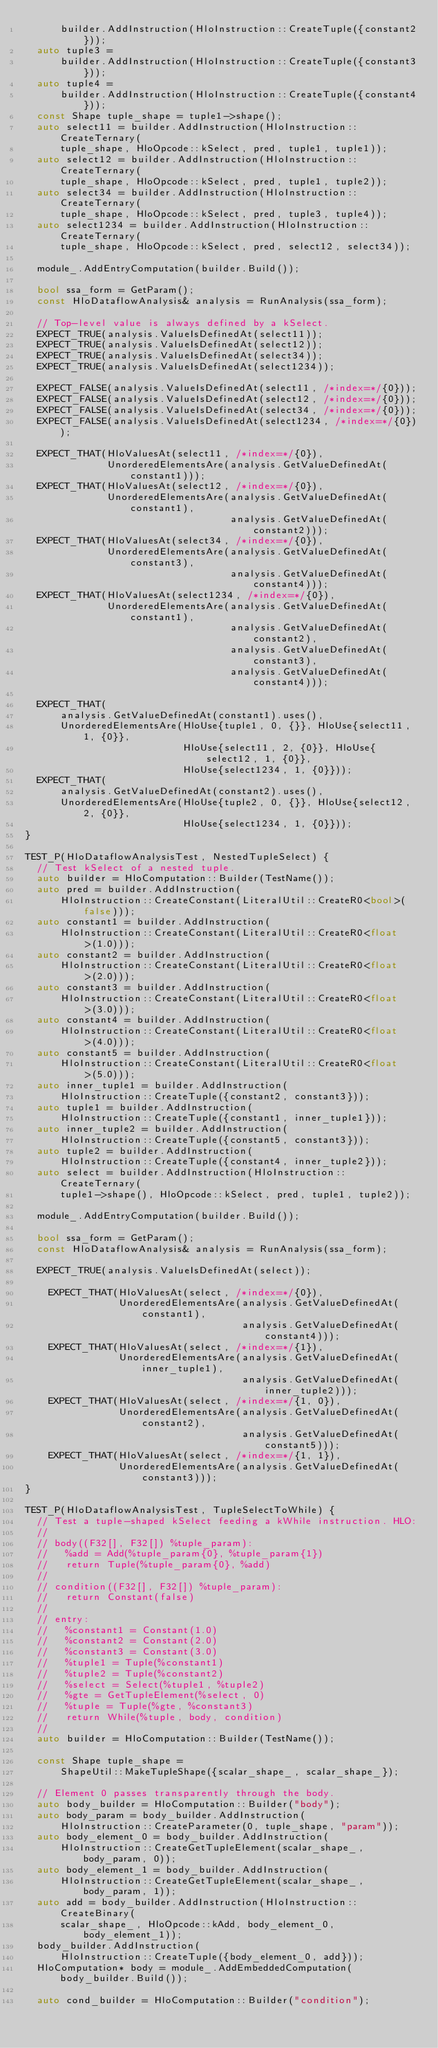Convert code to text. <code><loc_0><loc_0><loc_500><loc_500><_C++_>      builder.AddInstruction(HloInstruction::CreateTuple({constant2}));
  auto tuple3 =
      builder.AddInstruction(HloInstruction::CreateTuple({constant3}));
  auto tuple4 =
      builder.AddInstruction(HloInstruction::CreateTuple({constant4}));
  const Shape tuple_shape = tuple1->shape();
  auto select11 = builder.AddInstruction(HloInstruction::CreateTernary(
      tuple_shape, HloOpcode::kSelect, pred, tuple1, tuple1));
  auto select12 = builder.AddInstruction(HloInstruction::CreateTernary(
      tuple_shape, HloOpcode::kSelect, pred, tuple1, tuple2));
  auto select34 = builder.AddInstruction(HloInstruction::CreateTernary(
      tuple_shape, HloOpcode::kSelect, pred, tuple3, tuple4));
  auto select1234 = builder.AddInstruction(HloInstruction::CreateTernary(
      tuple_shape, HloOpcode::kSelect, pred, select12, select34));

  module_.AddEntryComputation(builder.Build());

  bool ssa_form = GetParam();
  const HloDataflowAnalysis& analysis = RunAnalysis(ssa_form);

  // Top-level value is always defined by a kSelect.
  EXPECT_TRUE(analysis.ValueIsDefinedAt(select11));
  EXPECT_TRUE(analysis.ValueIsDefinedAt(select12));
  EXPECT_TRUE(analysis.ValueIsDefinedAt(select34));
  EXPECT_TRUE(analysis.ValueIsDefinedAt(select1234));

  EXPECT_FALSE(analysis.ValueIsDefinedAt(select11, /*index=*/{0}));
  EXPECT_FALSE(analysis.ValueIsDefinedAt(select12, /*index=*/{0}));
  EXPECT_FALSE(analysis.ValueIsDefinedAt(select34, /*index=*/{0}));
  EXPECT_FALSE(analysis.ValueIsDefinedAt(select1234, /*index=*/{0}));

  EXPECT_THAT(HloValuesAt(select11, /*index=*/{0}),
              UnorderedElementsAre(analysis.GetValueDefinedAt(constant1)));
  EXPECT_THAT(HloValuesAt(select12, /*index=*/{0}),
              UnorderedElementsAre(analysis.GetValueDefinedAt(constant1),
                                   analysis.GetValueDefinedAt(constant2)));
  EXPECT_THAT(HloValuesAt(select34, /*index=*/{0}),
              UnorderedElementsAre(analysis.GetValueDefinedAt(constant3),
                                   analysis.GetValueDefinedAt(constant4)));
  EXPECT_THAT(HloValuesAt(select1234, /*index=*/{0}),
              UnorderedElementsAre(analysis.GetValueDefinedAt(constant1),
                                   analysis.GetValueDefinedAt(constant2),
                                   analysis.GetValueDefinedAt(constant3),
                                   analysis.GetValueDefinedAt(constant4)));

  EXPECT_THAT(
      analysis.GetValueDefinedAt(constant1).uses(),
      UnorderedElementsAre(HloUse{tuple1, 0, {}}, HloUse{select11, 1, {0}},
                           HloUse{select11, 2, {0}}, HloUse{select12, 1, {0}},
                           HloUse{select1234, 1, {0}}));
  EXPECT_THAT(
      analysis.GetValueDefinedAt(constant2).uses(),
      UnorderedElementsAre(HloUse{tuple2, 0, {}}, HloUse{select12, 2, {0}},
                           HloUse{select1234, 1, {0}}));
}

TEST_P(HloDataflowAnalysisTest, NestedTupleSelect) {
  // Test kSelect of a nested tuple.
  auto builder = HloComputation::Builder(TestName());
  auto pred = builder.AddInstruction(
      HloInstruction::CreateConstant(LiteralUtil::CreateR0<bool>(false)));
  auto constant1 = builder.AddInstruction(
      HloInstruction::CreateConstant(LiteralUtil::CreateR0<float>(1.0)));
  auto constant2 = builder.AddInstruction(
      HloInstruction::CreateConstant(LiteralUtil::CreateR0<float>(2.0)));
  auto constant3 = builder.AddInstruction(
      HloInstruction::CreateConstant(LiteralUtil::CreateR0<float>(3.0)));
  auto constant4 = builder.AddInstruction(
      HloInstruction::CreateConstant(LiteralUtil::CreateR0<float>(4.0)));
  auto constant5 = builder.AddInstruction(
      HloInstruction::CreateConstant(LiteralUtil::CreateR0<float>(5.0)));
  auto inner_tuple1 = builder.AddInstruction(
      HloInstruction::CreateTuple({constant2, constant3}));
  auto tuple1 = builder.AddInstruction(
      HloInstruction::CreateTuple({constant1, inner_tuple1}));
  auto inner_tuple2 = builder.AddInstruction(
      HloInstruction::CreateTuple({constant5, constant3}));
  auto tuple2 = builder.AddInstruction(
      HloInstruction::CreateTuple({constant4, inner_tuple2}));
  auto select = builder.AddInstruction(HloInstruction::CreateTernary(
      tuple1->shape(), HloOpcode::kSelect, pred, tuple1, tuple2));

  module_.AddEntryComputation(builder.Build());

  bool ssa_form = GetParam();
  const HloDataflowAnalysis& analysis = RunAnalysis(ssa_form);

  EXPECT_TRUE(analysis.ValueIsDefinedAt(select));

    EXPECT_THAT(HloValuesAt(select, /*index=*/{0}),
                UnorderedElementsAre(analysis.GetValueDefinedAt(constant1),
                                     analysis.GetValueDefinedAt(constant4)));
    EXPECT_THAT(HloValuesAt(select, /*index=*/{1}),
                UnorderedElementsAre(analysis.GetValueDefinedAt(inner_tuple1),
                                     analysis.GetValueDefinedAt(inner_tuple2)));
    EXPECT_THAT(HloValuesAt(select, /*index=*/{1, 0}),
                UnorderedElementsAre(analysis.GetValueDefinedAt(constant2),
                                     analysis.GetValueDefinedAt(constant5)));
    EXPECT_THAT(HloValuesAt(select, /*index=*/{1, 1}),
                UnorderedElementsAre(analysis.GetValueDefinedAt(constant3)));
}

TEST_P(HloDataflowAnalysisTest, TupleSelectToWhile) {
  // Test a tuple-shaped kSelect feeding a kWhile instruction. HLO:
  //
  // body((F32[], F32[]) %tuple_param):
  //   %add = Add(%tuple_param{0}, %tuple_param{1})
  //   return Tuple(%tuple_param{0}, %add)
  //
  // condition((F32[], F32[]) %tuple_param):
  //   return Constant(false)
  //
  // entry:
  //   %constant1 = Constant(1.0)
  //   %constant2 = Constant(2.0)
  //   %constant3 = Constant(3.0)
  //   %tuple1 = Tuple(%constant1)
  //   %tuple2 = Tuple(%constant2)
  //   %select = Select(%tuple1, %tuple2)
  //   %gte = GetTupleElement(%select, 0)
  //   %tuple = Tuple(%gte, %constant3)
  //   return While(%tuple, body, condition)
  //
  auto builder = HloComputation::Builder(TestName());

  const Shape tuple_shape =
      ShapeUtil::MakeTupleShape({scalar_shape_, scalar_shape_});

  // Element 0 passes transparently through the body.
  auto body_builder = HloComputation::Builder("body");
  auto body_param = body_builder.AddInstruction(
      HloInstruction::CreateParameter(0, tuple_shape, "param"));
  auto body_element_0 = body_builder.AddInstruction(
      HloInstruction::CreateGetTupleElement(scalar_shape_, body_param, 0));
  auto body_element_1 = body_builder.AddInstruction(
      HloInstruction::CreateGetTupleElement(scalar_shape_, body_param, 1));
  auto add = body_builder.AddInstruction(HloInstruction::CreateBinary(
      scalar_shape_, HloOpcode::kAdd, body_element_0, body_element_1));
  body_builder.AddInstruction(
      HloInstruction::CreateTuple({body_element_0, add}));
  HloComputation* body = module_.AddEmbeddedComputation(body_builder.Build());

  auto cond_builder = HloComputation::Builder("condition");</code> 